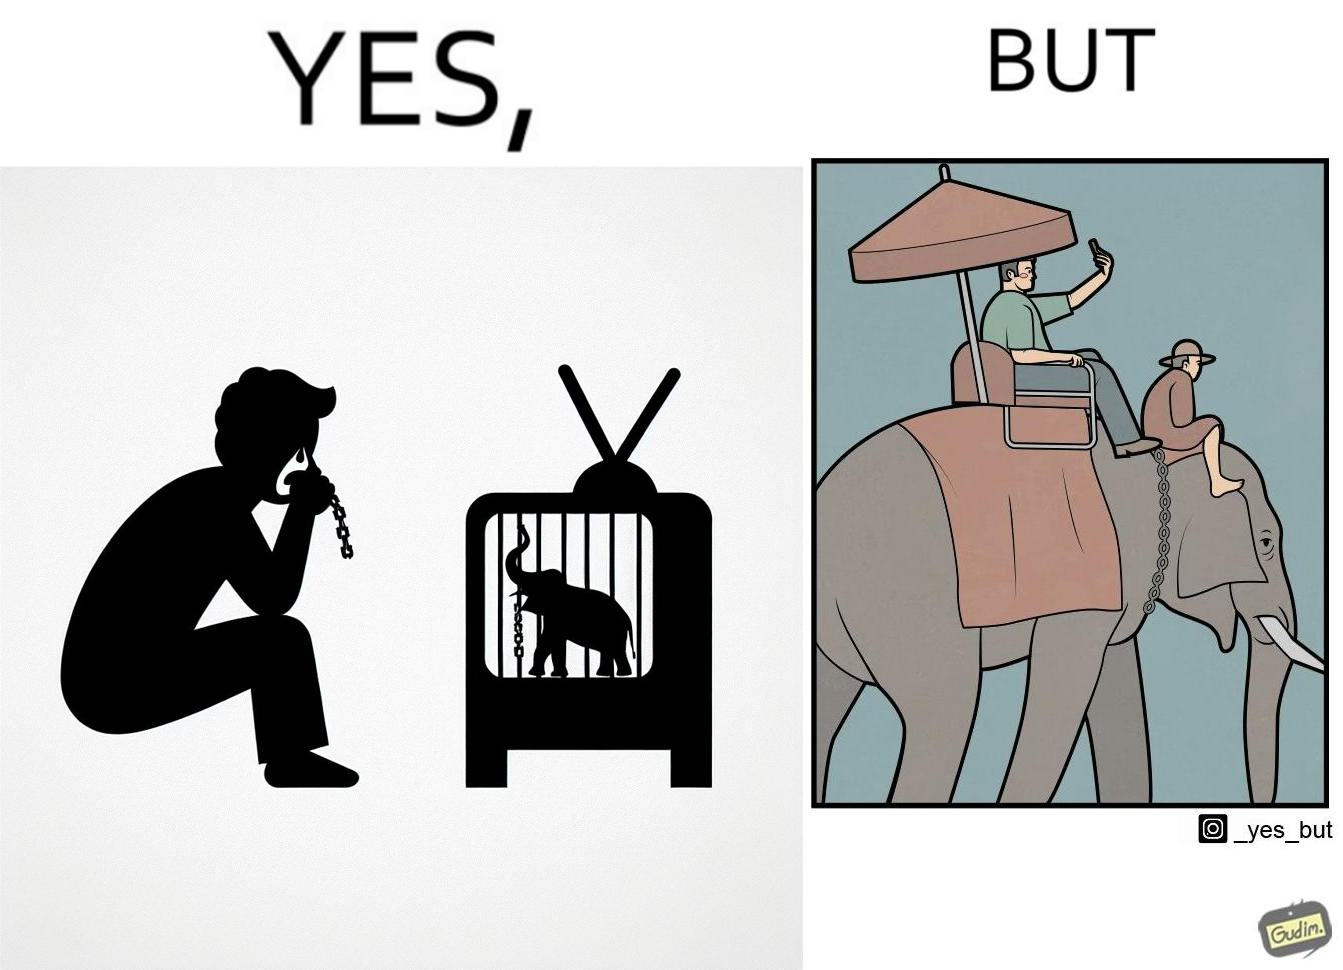What does this image depict? The image is ironic, because the people who get sentimental over imprisoned animal while watching TV shows often feel okay when using animals for labor 